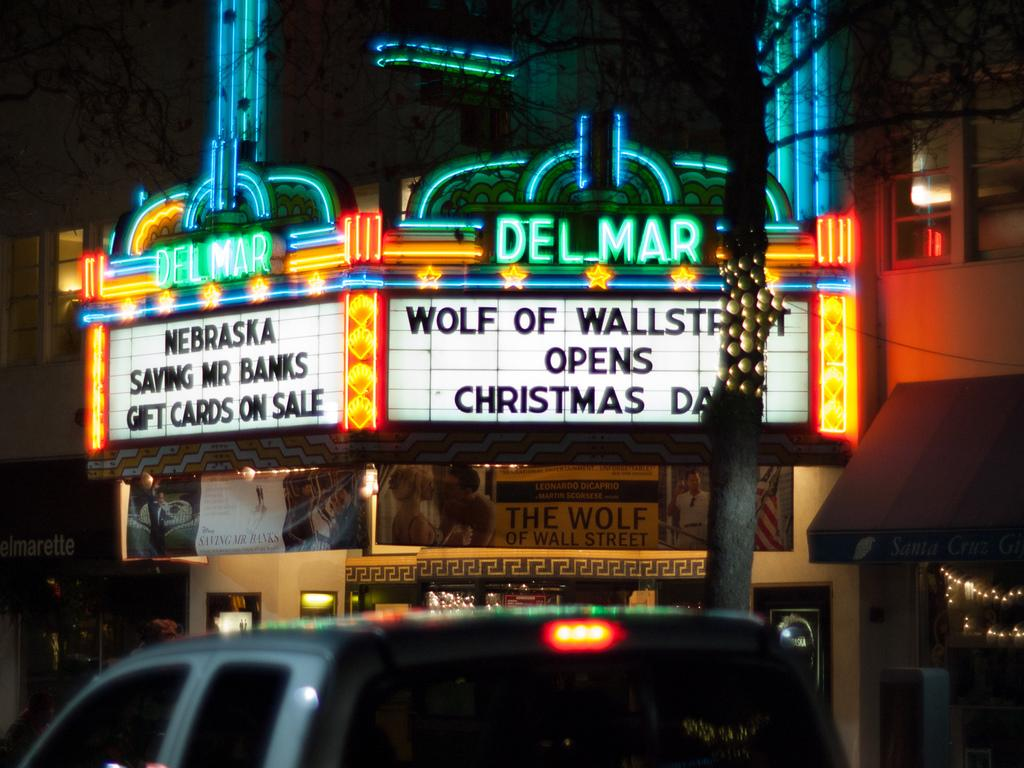<image>
Relay a brief, clear account of the picture shown. A lit sign advertising shows at the Delmar theater can be seen with a car in front of it. 